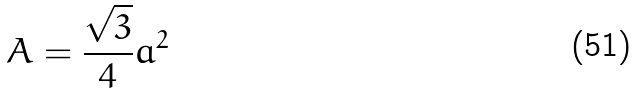<formula> <loc_0><loc_0><loc_500><loc_500>A = \frac { \sqrt { 3 } } { 4 } a ^ { 2 }</formula> 